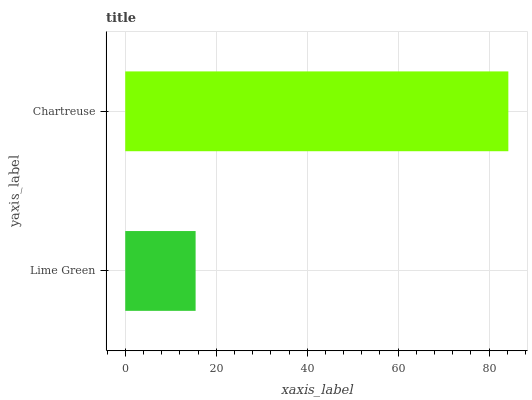Is Lime Green the minimum?
Answer yes or no. Yes. Is Chartreuse the maximum?
Answer yes or no. Yes. Is Chartreuse the minimum?
Answer yes or no. No. Is Chartreuse greater than Lime Green?
Answer yes or no. Yes. Is Lime Green less than Chartreuse?
Answer yes or no. Yes. Is Lime Green greater than Chartreuse?
Answer yes or no. No. Is Chartreuse less than Lime Green?
Answer yes or no. No. Is Chartreuse the high median?
Answer yes or no. Yes. Is Lime Green the low median?
Answer yes or no. Yes. Is Lime Green the high median?
Answer yes or no. No. Is Chartreuse the low median?
Answer yes or no. No. 